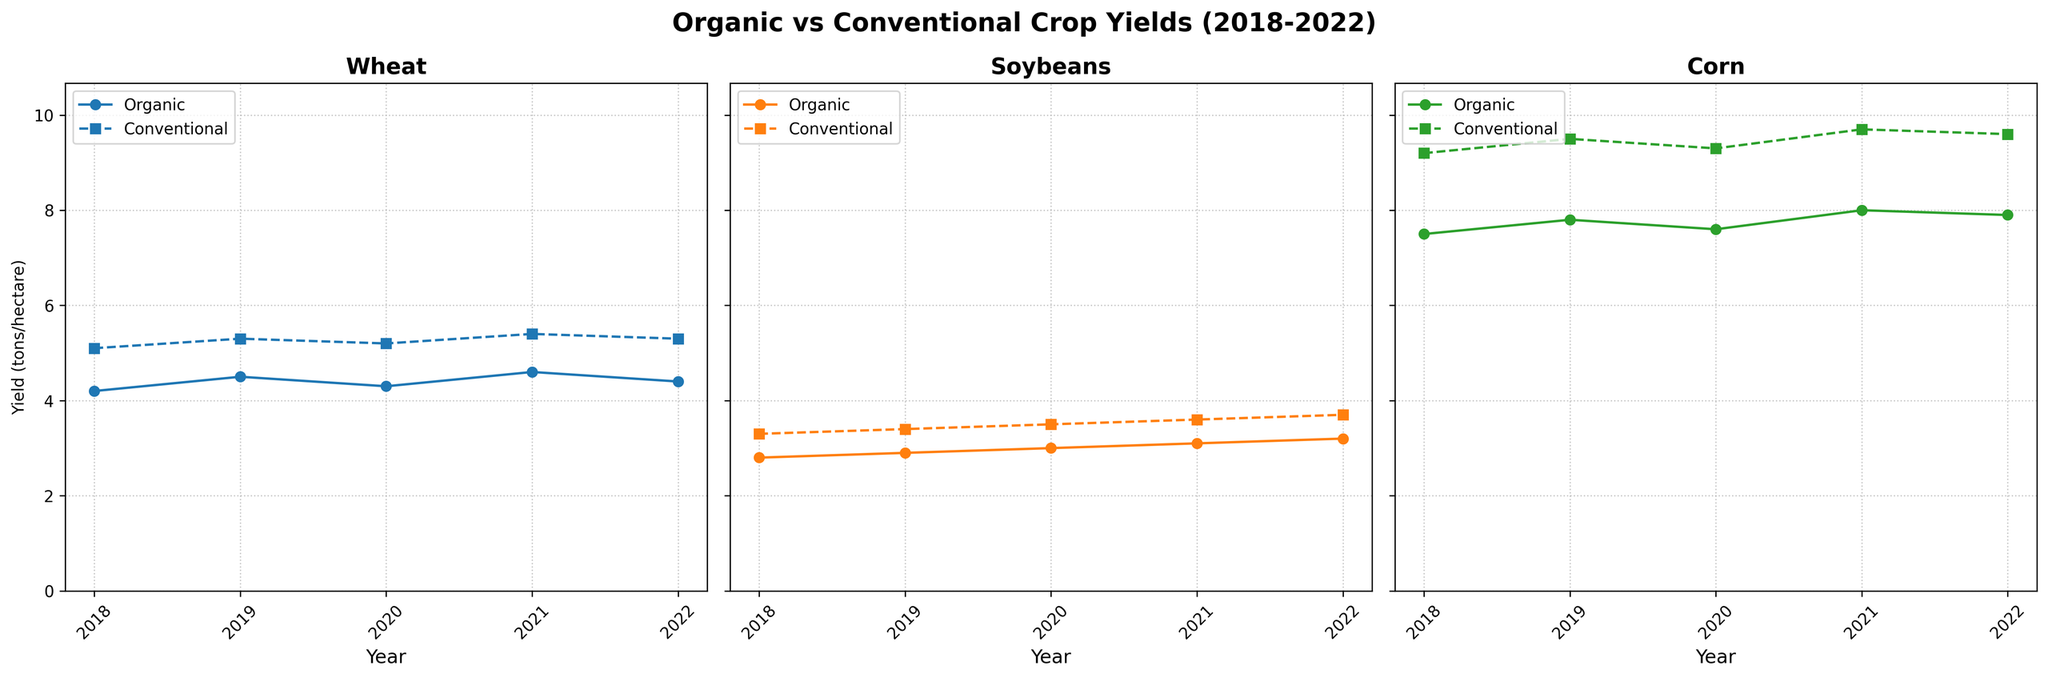What's the title of the chart? The title is at the top of the figure, written in bold font. It provides a summary of the data being presented.
Answer: Organic vs Conventional Crop Yields (2018-2022) How many crops are compared in the figure? Each subplot represents a different crop. By counting the number of subplots, we can determine the total number of crops compared.
Answer: 3 What are the colors used to represent organic and conventional yields? The color for each yield type can be discovered by looking at the plot lines and their respective legends.
Answer: Organic: different colors for different crops, Conventional: different colors for different crops but dashed lines In which year did organic wheat yield reach its highest value? Look at the subplot for Wheat and identify the highest point of the line representing Organic Yield over the years.
Answer: 2021 Which crop shows the smallest difference between organic and conventional yields in 2022? By comparing the gap between organic and conventional yield lines in each subplot for the year 2022, you can determine the smallest difference.
Answer: Soybeans What is the average organic corn yield from 2018 to 2022? To get the average, sum up the organic corn yields for each year and divide by the number of years (5). (7.5 + 7.8 + 7.6 + 8.0 + 7.9) / 5 = 7.76
Answer: 7.76 Between 2018 and 2022, did any crop's organic yield exceed the conventional yield? Compare the highest points of the organic yield lines with the highest points of the conventional yield lines in each subplot to check for any intersection.
Answer: No Which crop exhibits the most consistent organic yield over the 5 years? Look for the subplot where the organic yield line has the least fluctuation across the 5 years.
Answer: Soybeans In which year did the conventional corn yield peak? Look at the subplot for Corn and identify the highest point of the dashed line (Conventional Yield) over the 5 years.
Answer: 2021 How does the trend of organic soybean yield compare to the trend of conventional soybean yield over the years? Compare the general direction (increasing, decreasing, stable) of the organic soybean yield line with the conventional soybean yield line in the Soybean subplot.
Answer: Both trends are increasing 